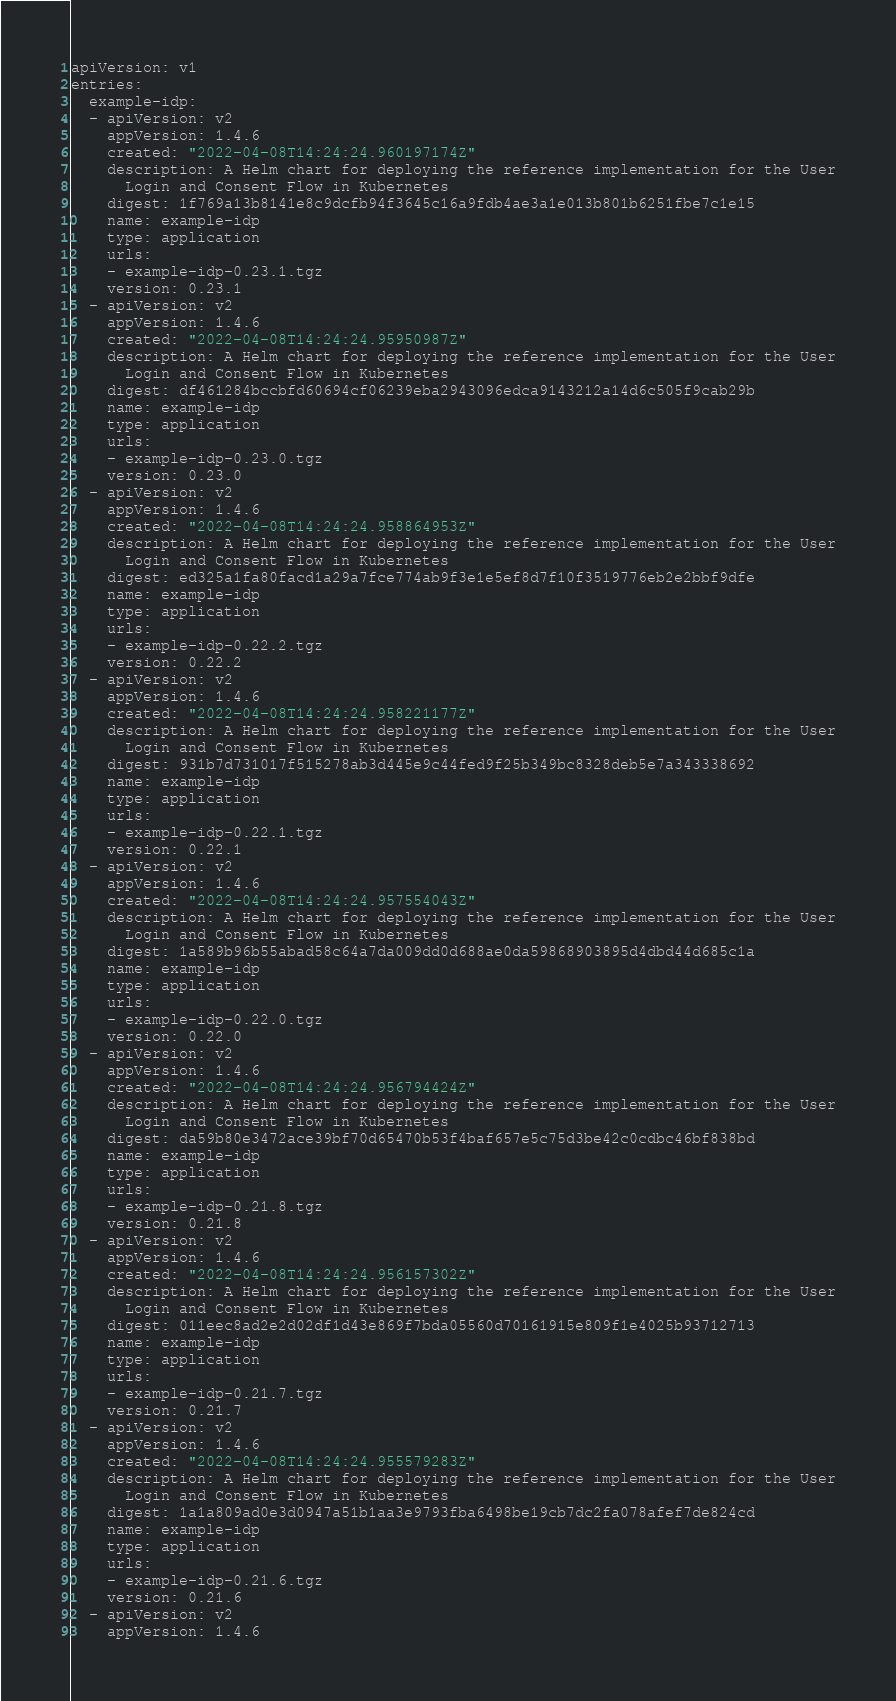Convert code to text. <code><loc_0><loc_0><loc_500><loc_500><_YAML_>apiVersion: v1
entries:
  example-idp:
  - apiVersion: v2
    appVersion: 1.4.6
    created: "2022-04-08T14:24:24.960197174Z"
    description: A Helm chart for deploying the reference implementation for the User
      Login and Consent Flow in Kubernetes
    digest: 1f769a13b8141e8c9dcfb94f3645c16a9fdb4ae3a1e013b801b6251fbe7c1e15
    name: example-idp
    type: application
    urls:
    - example-idp-0.23.1.tgz
    version: 0.23.1
  - apiVersion: v2
    appVersion: 1.4.6
    created: "2022-04-08T14:24:24.95950987Z"
    description: A Helm chart for deploying the reference implementation for the User
      Login and Consent Flow in Kubernetes
    digest: df461284bccbfd60694cf06239eba2943096edca9143212a14d6c505f9cab29b
    name: example-idp
    type: application
    urls:
    - example-idp-0.23.0.tgz
    version: 0.23.0
  - apiVersion: v2
    appVersion: 1.4.6
    created: "2022-04-08T14:24:24.958864953Z"
    description: A Helm chart for deploying the reference implementation for the User
      Login and Consent Flow in Kubernetes
    digest: ed325a1fa80facd1a29a7fce774ab9f3e1e5ef8d7f10f3519776eb2e2bbf9dfe
    name: example-idp
    type: application
    urls:
    - example-idp-0.22.2.tgz
    version: 0.22.2
  - apiVersion: v2
    appVersion: 1.4.6
    created: "2022-04-08T14:24:24.958221177Z"
    description: A Helm chart for deploying the reference implementation for the User
      Login and Consent Flow in Kubernetes
    digest: 931b7d731017f515278ab3d445e9c44fed9f25b349bc8328deb5e7a343338692
    name: example-idp
    type: application
    urls:
    - example-idp-0.22.1.tgz
    version: 0.22.1
  - apiVersion: v2
    appVersion: 1.4.6
    created: "2022-04-08T14:24:24.957554043Z"
    description: A Helm chart for deploying the reference implementation for the User
      Login and Consent Flow in Kubernetes
    digest: 1a589b96b55abad58c64a7da009dd0d688ae0da59868903895d4dbd44d685c1a
    name: example-idp
    type: application
    urls:
    - example-idp-0.22.0.tgz
    version: 0.22.0
  - apiVersion: v2
    appVersion: 1.4.6
    created: "2022-04-08T14:24:24.956794424Z"
    description: A Helm chart for deploying the reference implementation for the User
      Login and Consent Flow in Kubernetes
    digest: da59b80e3472ace39bf70d65470b53f4baf657e5c75d3be42c0cdbc46bf838bd
    name: example-idp
    type: application
    urls:
    - example-idp-0.21.8.tgz
    version: 0.21.8
  - apiVersion: v2
    appVersion: 1.4.6
    created: "2022-04-08T14:24:24.956157302Z"
    description: A Helm chart for deploying the reference implementation for the User
      Login and Consent Flow in Kubernetes
    digest: 011eec8ad2e2d02df1d43e869f7bda05560d70161915e809f1e4025b93712713
    name: example-idp
    type: application
    urls:
    - example-idp-0.21.7.tgz
    version: 0.21.7
  - apiVersion: v2
    appVersion: 1.4.6
    created: "2022-04-08T14:24:24.955579283Z"
    description: A Helm chart for deploying the reference implementation for the User
      Login and Consent Flow in Kubernetes
    digest: 1a1a809ad0e3d0947a51b1aa3e9793fba6498be19cb7dc2fa078afef7de824cd
    name: example-idp
    type: application
    urls:
    - example-idp-0.21.6.tgz
    version: 0.21.6
  - apiVersion: v2
    appVersion: 1.4.6</code> 